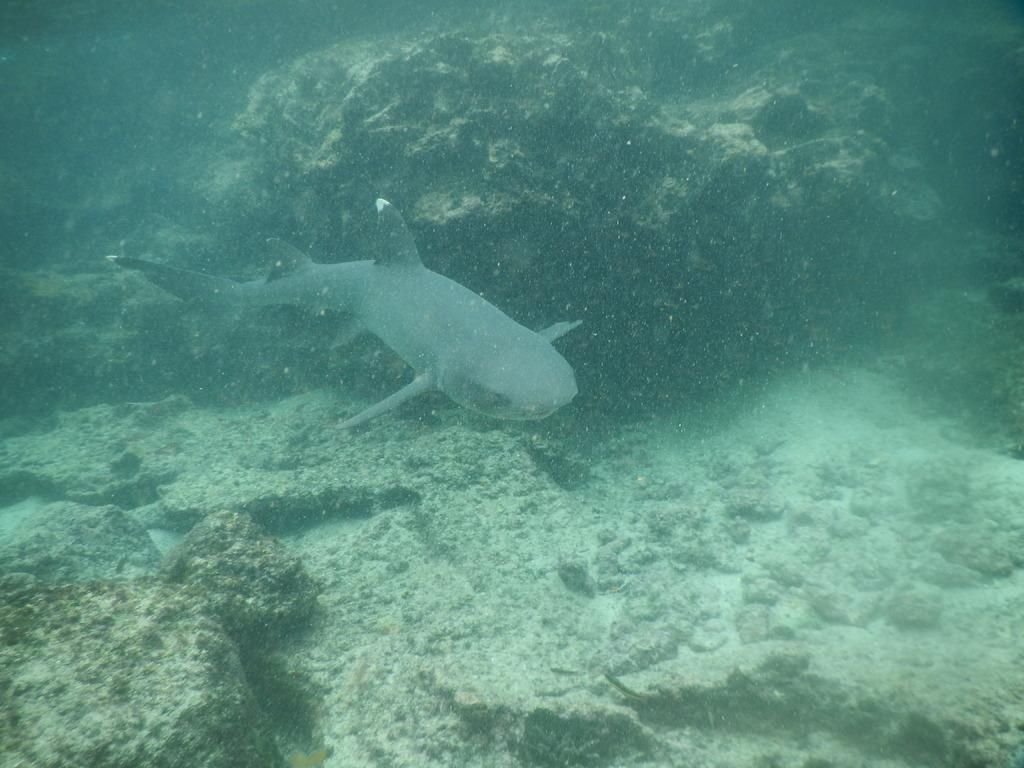What animal can be seen in the image? There is a dolphin under the water in the image. Can you describe the environment in which the dolphin is located? The dolphin is underwater in the image. How does the dolphin use its throat to fly in the image? Dolphins do not fly, and they do not have the ability to use their throats for flying. The dolphin in the image is underwater and not flying. 